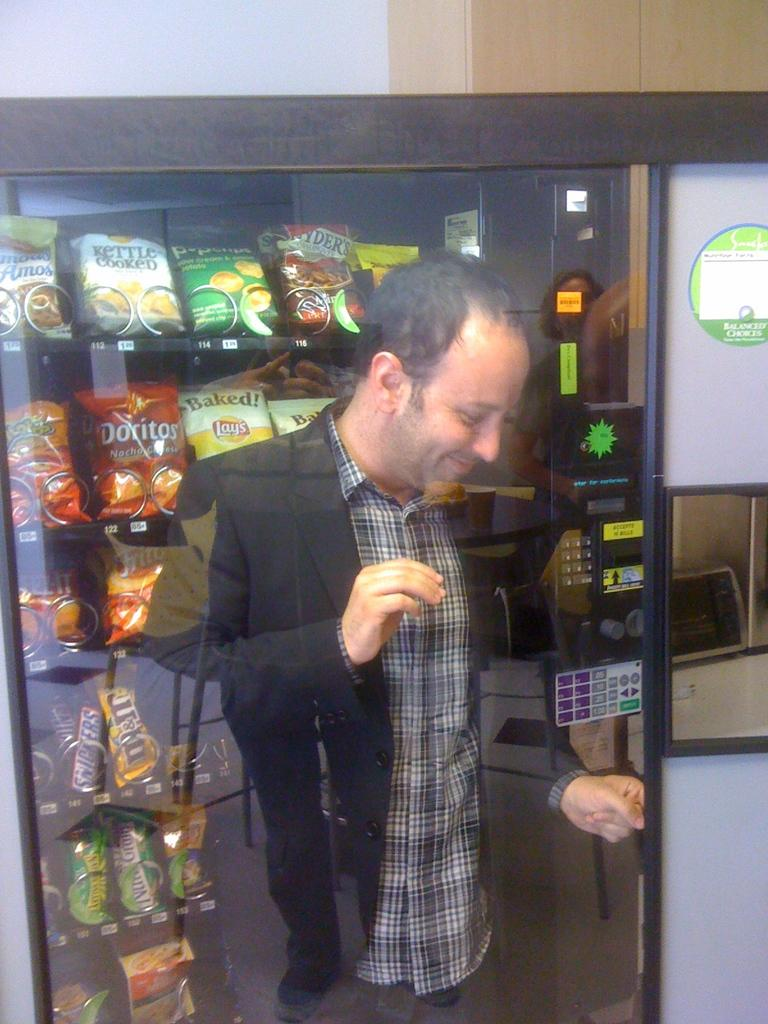What object is present in the image that people typically drink from? There is a glass in the image. Who is standing behind the glass in the image? A man is standing behind the glass. What can be seen in the background of the image? There are packets and objects in racks visible in the background, and there is also a wall in the background. What type of crown is the man wearing in the image? There is no crown present in the image; the man is standing behind a glass. 